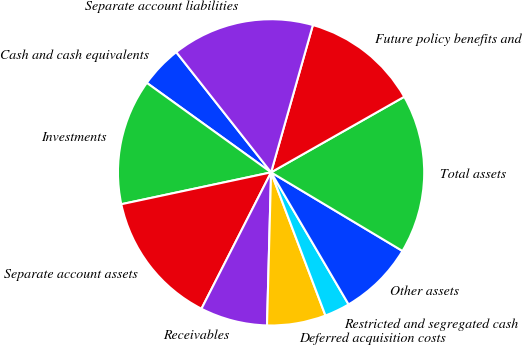<chart> <loc_0><loc_0><loc_500><loc_500><pie_chart><fcel>Cash and cash equivalents<fcel>Investments<fcel>Separate account assets<fcel>Receivables<fcel>Deferred acquisition costs<fcel>Restricted and segregated cash<fcel>Other assets<fcel>Total assets<fcel>Future policy benefits and<fcel>Separate account liabilities<nl><fcel>4.44%<fcel>13.27%<fcel>14.15%<fcel>7.09%<fcel>6.2%<fcel>2.67%<fcel>7.97%<fcel>16.8%<fcel>12.38%<fcel>15.03%<nl></chart> 